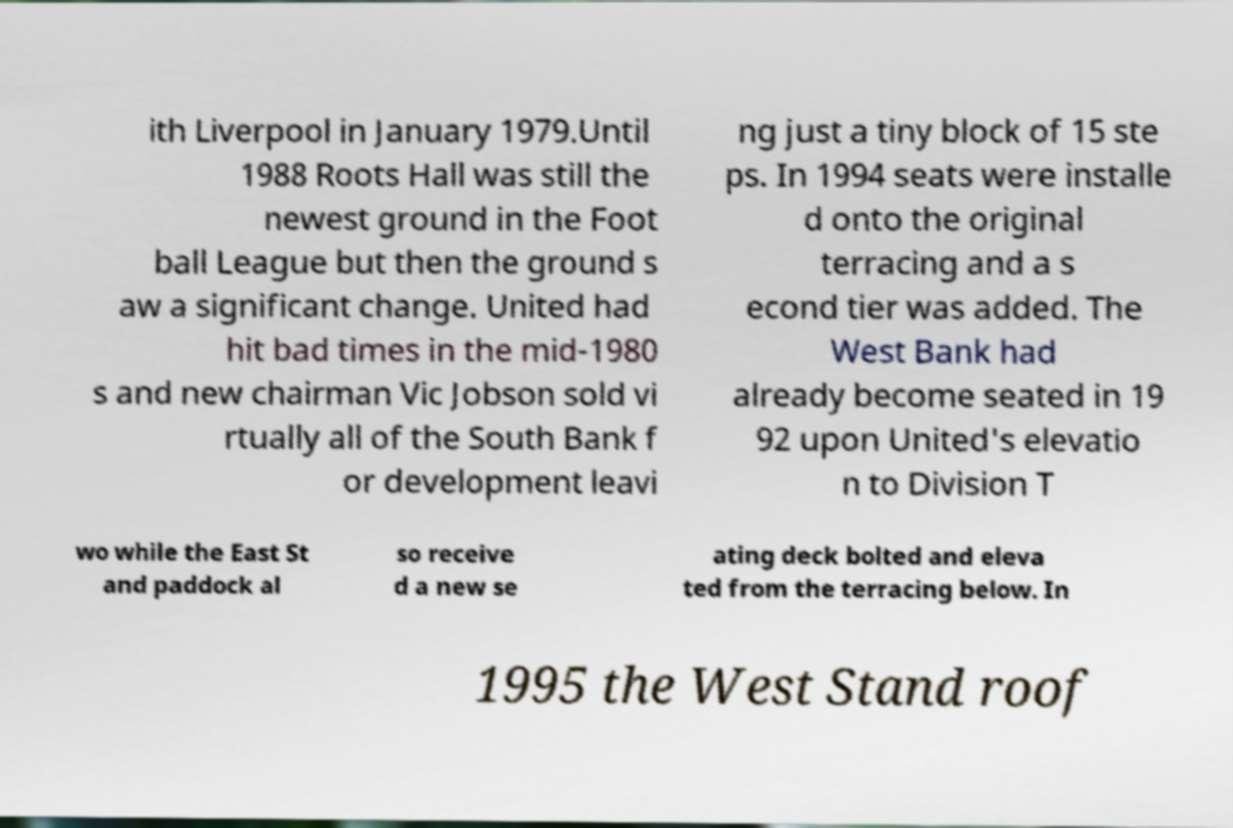Please read and relay the text visible in this image. What does it say? ith Liverpool in January 1979.Until 1988 Roots Hall was still the newest ground in the Foot ball League but then the ground s aw a significant change. United had hit bad times in the mid-1980 s and new chairman Vic Jobson sold vi rtually all of the South Bank f or development leavi ng just a tiny block of 15 ste ps. In 1994 seats were installe d onto the original terracing and a s econd tier was added. The West Bank had already become seated in 19 92 upon United's elevatio n to Division T wo while the East St and paddock al so receive d a new se ating deck bolted and eleva ted from the terracing below. In 1995 the West Stand roof 